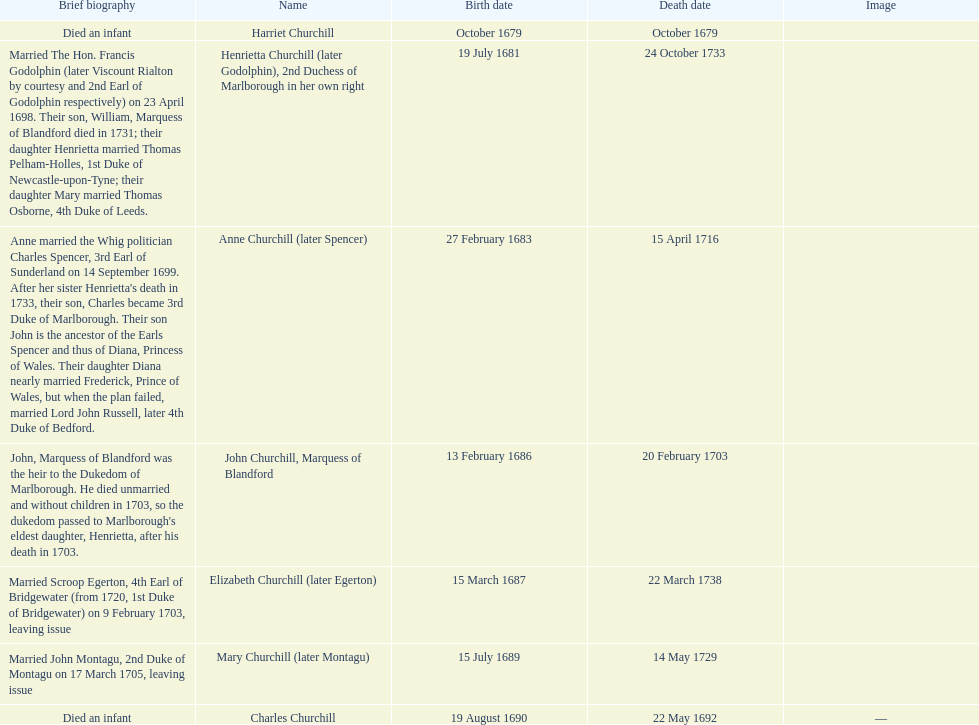Who was born before henrietta churchhill? Harriet Churchill. 